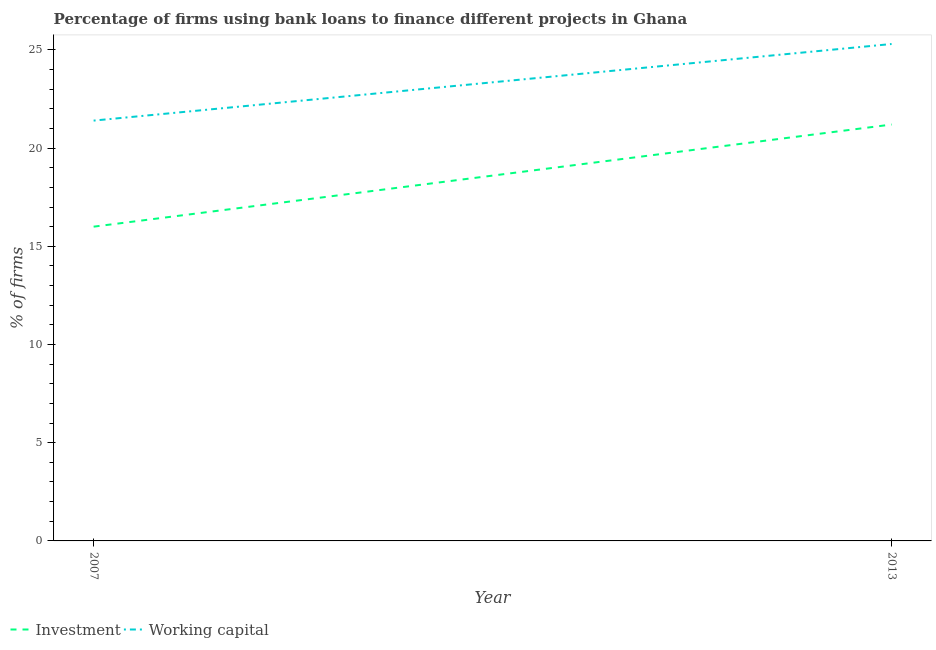What is the percentage of firms using banks to finance working capital in 2013?
Your response must be concise. 25.3. Across all years, what is the maximum percentage of firms using banks to finance investment?
Your answer should be very brief. 21.2. Across all years, what is the minimum percentage of firms using banks to finance working capital?
Provide a succinct answer. 21.4. What is the total percentage of firms using banks to finance investment in the graph?
Your answer should be very brief. 37.2. What is the difference between the percentage of firms using banks to finance working capital in 2007 and that in 2013?
Provide a short and direct response. -3.9. What is the average percentage of firms using banks to finance working capital per year?
Offer a terse response. 23.35. In the year 2007, what is the difference between the percentage of firms using banks to finance working capital and percentage of firms using banks to finance investment?
Make the answer very short. 5.4. In how many years, is the percentage of firms using banks to finance investment greater than 1 %?
Make the answer very short. 2. What is the ratio of the percentage of firms using banks to finance working capital in 2007 to that in 2013?
Your response must be concise. 0.85. Is the percentage of firms using banks to finance investment in 2007 less than that in 2013?
Your answer should be very brief. Yes. In how many years, is the percentage of firms using banks to finance working capital greater than the average percentage of firms using banks to finance working capital taken over all years?
Your answer should be very brief. 1. Does the percentage of firms using banks to finance investment monotonically increase over the years?
Offer a very short reply. Yes. Is the percentage of firms using banks to finance investment strictly greater than the percentage of firms using banks to finance working capital over the years?
Make the answer very short. No. How many years are there in the graph?
Your answer should be compact. 2. What is the difference between two consecutive major ticks on the Y-axis?
Keep it short and to the point. 5. Are the values on the major ticks of Y-axis written in scientific E-notation?
Keep it short and to the point. No. Does the graph contain any zero values?
Ensure brevity in your answer.  No. Does the graph contain grids?
Your answer should be compact. No. How are the legend labels stacked?
Make the answer very short. Horizontal. What is the title of the graph?
Your answer should be very brief. Percentage of firms using bank loans to finance different projects in Ghana. Does "Education" appear as one of the legend labels in the graph?
Offer a very short reply. No. What is the label or title of the Y-axis?
Make the answer very short. % of firms. What is the % of firms in Working capital in 2007?
Your answer should be compact. 21.4. What is the % of firms in Investment in 2013?
Offer a terse response. 21.2. What is the % of firms of Working capital in 2013?
Offer a very short reply. 25.3. Across all years, what is the maximum % of firms in Investment?
Provide a short and direct response. 21.2. Across all years, what is the maximum % of firms of Working capital?
Give a very brief answer. 25.3. Across all years, what is the minimum % of firms of Investment?
Provide a short and direct response. 16. Across all years, what is the minimum % of firms in Working capital?
Keep it short and to the point. 21.4. What is the total % of firms in Investment in the graph?
Give a very brief answer. 37.2. What is the total % of firms in Working capital in the graph?
Offer a terse response. 46.7. What is the difference between the % of firms of Working capital in 2007 and that in 2013?
Your response must be concise. -3.9. What is the average % of firms in Investment per year?
Give a very brief answer. 18.6. What is the average % of firms in Working capital per year?
Offer a terse response. 23.35. In the year 2007, what is the difference between the % of firms in Investment and % of firms in Working capital?
Keep it short and to the point. -5.4. In the year 2013, what is the difference between the % of firms of Investment and % of firms of Working capital?
Offer a very short reply. -4.1. What is the ratio of the % of firms in Investment in 2007 to that in 2013?
Provide a succinct answer. 0.75. What is the ratio of the % of firms in Working capital in 2007 to that in 2013?
Your answer should be very brief. 0.85. What is the difference between the highest and the lowest % of firms in Working capital?
Your response must be concise. 3.9. 